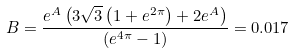<formula> <loc_0><loc_0><loc_500><loc_500>B = \frac { e ^ { A } \left ( 3 \sqrt { 3 } \left ( 1 + e ^ { 2 \pi } \right ) + 2 e ^ { A } \right ) } { \left ( e ^ { 4 \pi } - 1 \right ) } = 0 . 0 1 7</formula> 